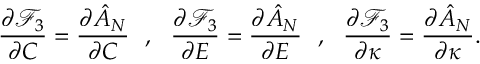<formula> <loc_0><loc_0><loc_500><loc_500>\frac { \partial \mathcal { F } _ { 3 } } { \partial C } = \frac { \partial \hat { A } _ { N } } { \partial C } , \frac { \partial \mathcal { F } _ { 3 } } { \partial E } = \frac { \partial \hat { A } _ { N } } { \partial E } , \frac { \partial \mathcal { F } _ { 3 } } { \partial \kappa } = \frac { \partial \hat { A } _ { N } } { \partial \kappa } .</formula> 